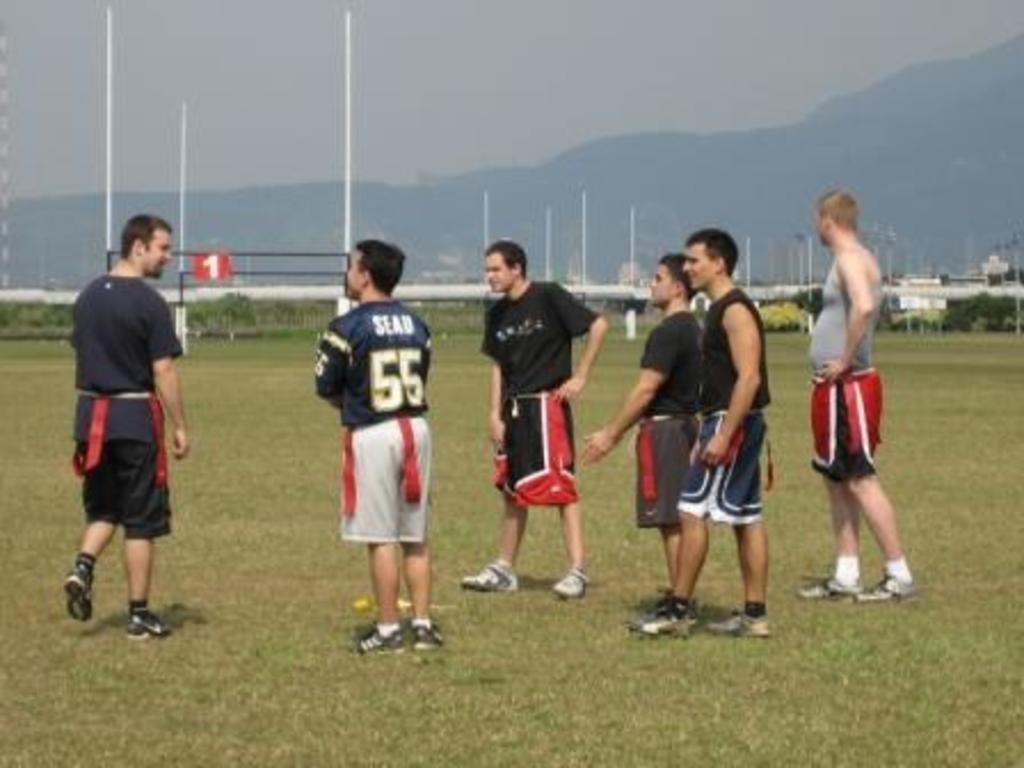Please provide a concise description of this image. In this picture we can observe some men standing in the ground. There is some grass on the ground. We can observe white color balls. There are some plants. In the background we can observe hills and sky. 